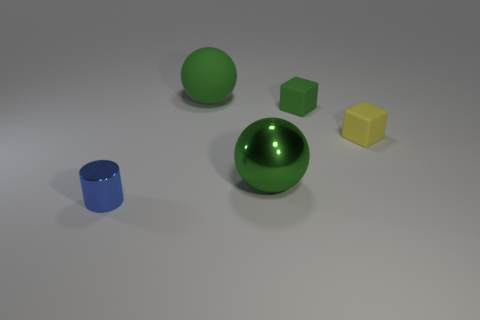What can you infer about the light source in this image? The image suggests a single, diffused light source positioned above the objects, creating soft shadows on the ground to the left of each object. The reflections on the glossy surfaces, particularly on the larger green sphere, indicate a light source that is not directly visible in the image. 